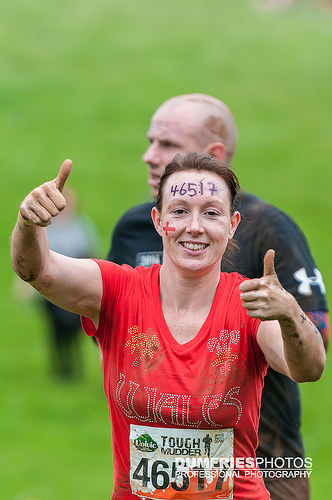<image>
Is the women in front of the man? Yes. The women is positioned in front of the man, appearing closer to the camera viewpoint. 